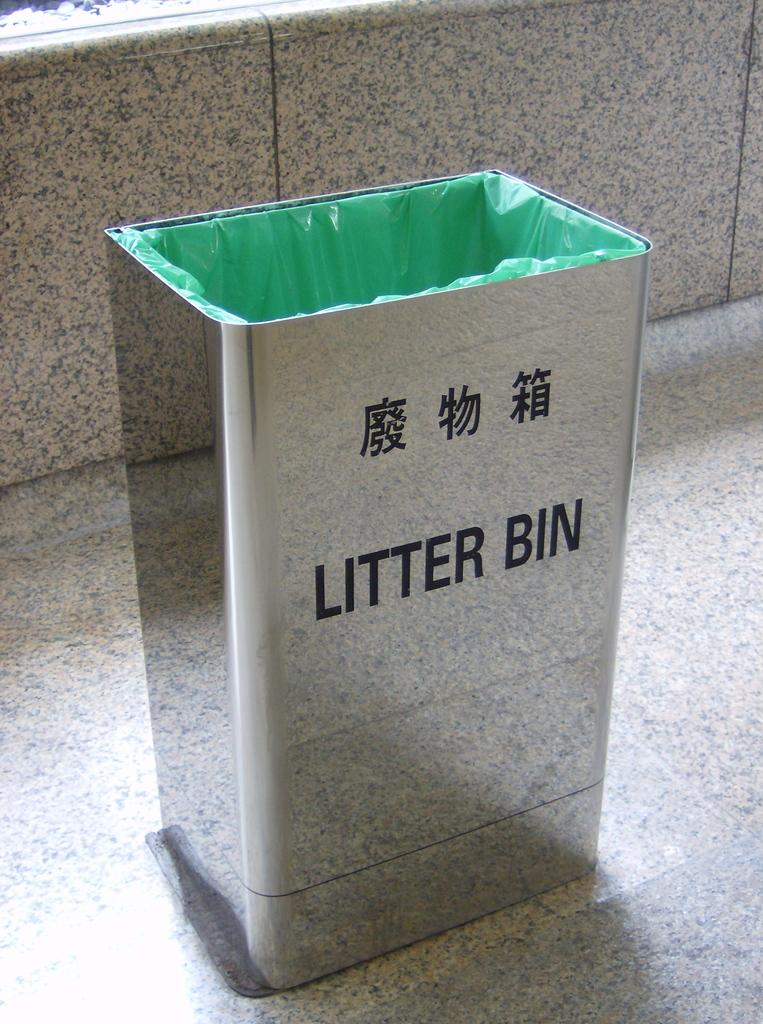<image>
Present a compact description of the photo's key features. A shiny silver litter bin with asian characters on it. 